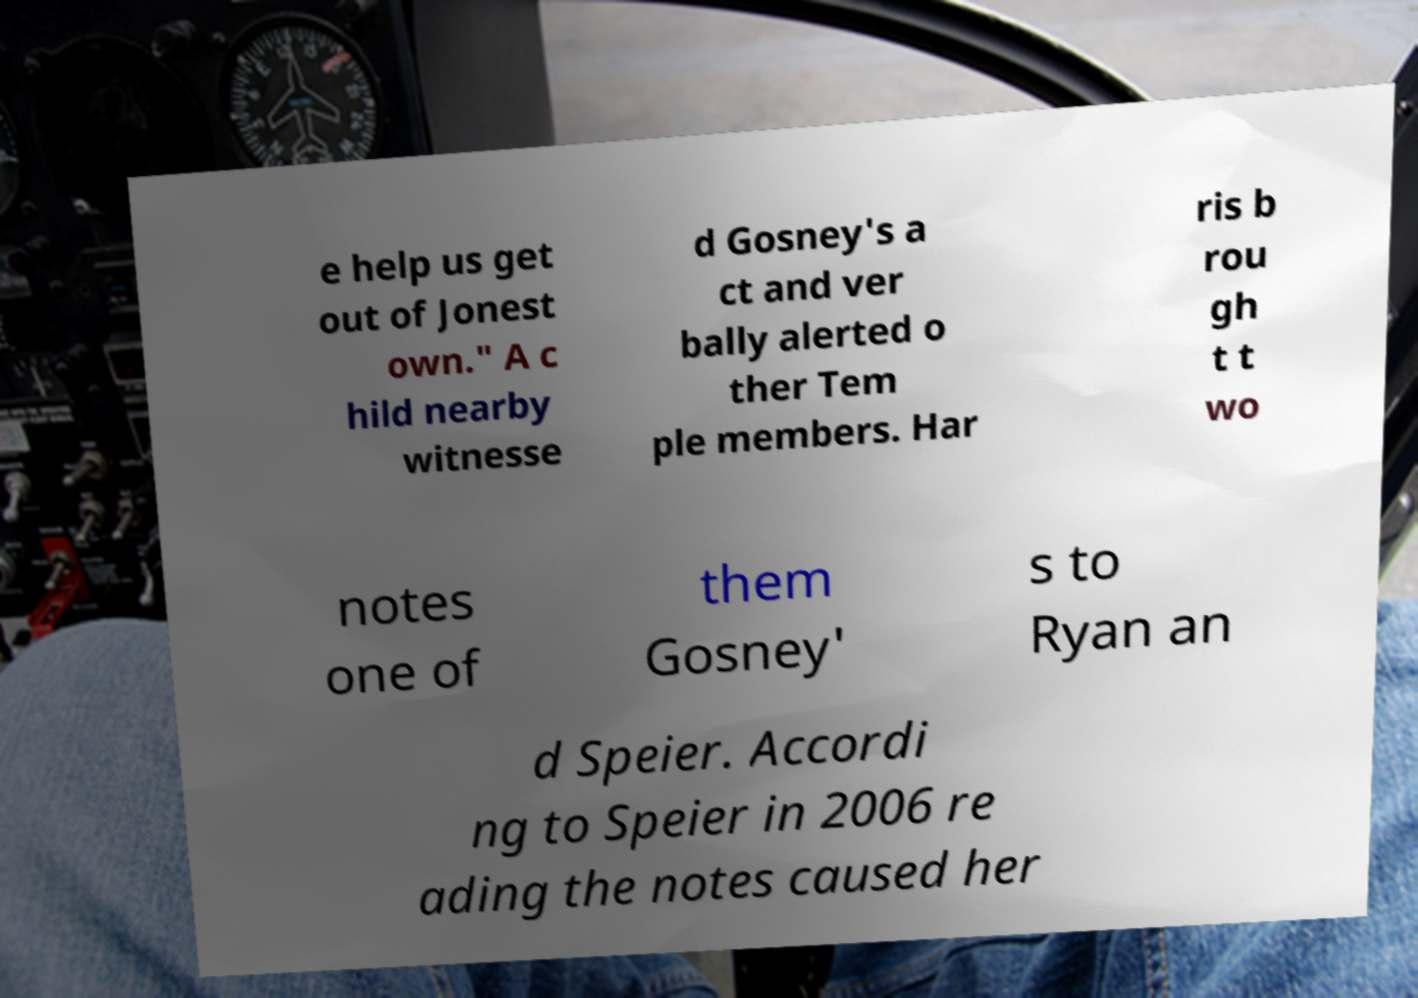I need the written content from this picture converted into text. Can you do that? e help us get out of Jonest own." A c hild nearby witnesse d Gosney's a ct and ver bally alerted o ther Tem ple members. Har ris b rou gh t t wo notes one of them Gosney' s to Ryan an d Speier. Accordi ng to Speier in 2006 re ading the notes caused her 